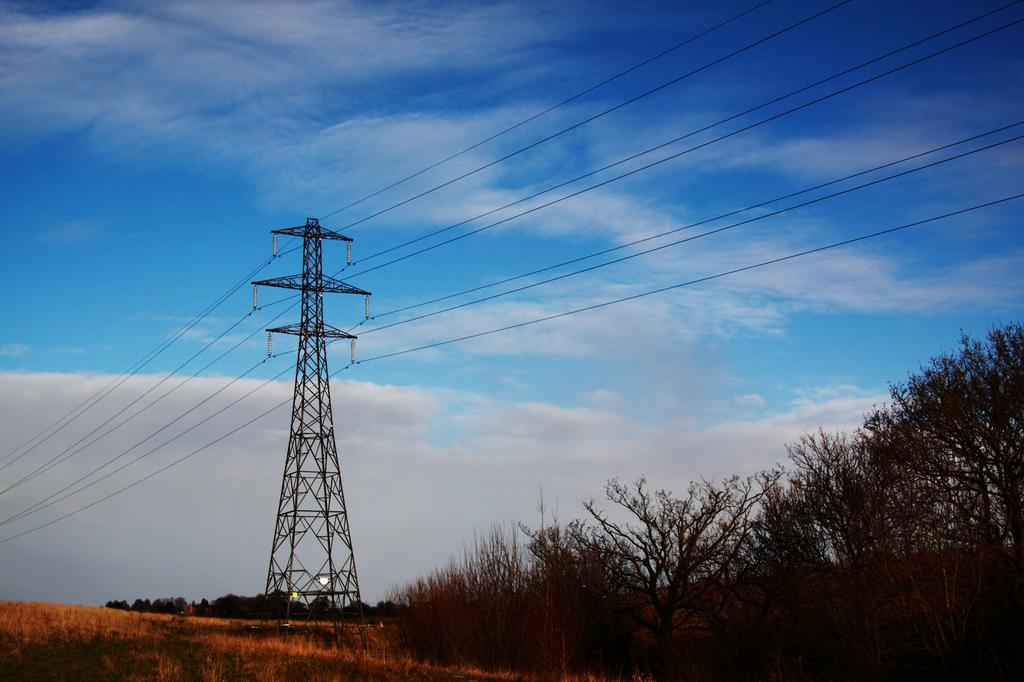What type of vegetation can be seen in the image? There are trees in the image. What structure is visible in the background of the image? There is an electric tower in the background of the image. What colors are present in the sky in the image? The sky is blue and white in color. What type of flower is blooming in the image? There are no flowers present in the image; it features trees and an electric tower. What month is it in the image? The image does not provide any information about the month; it only shows trees, an electric tower, and the sky. 